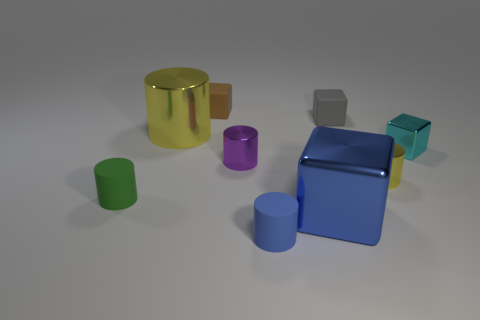There is a tiny object that is the same color as the big cylinder; what is it made of?
Your response must be concise. Metal. How many matte things are either tiny yellow things or blue blocks?
Make the answer very short. 0. How big is the brown rubber cube?
Provide a short and direct response. Small. Is the size of the cyan thing the same as the blue metal thing?
Your answer should be compact. No. There is a cylinder behind the tiny purple thing; what material is it?
Your answer should be very brief. Metal. There is a purple thing that is the same shape as the big yellow metallic object; what material is it?
Offer a terse response. Metal. Are there any rubber cubes to the right of the shiny cylinder to the right of the gray thing?
Offer a very short reply. No. Does the tiny brown thing have the same shape as the blue metal thing?
Your response must be concise. Yes. There is a small purple thing that is the same material as the tiny cyan block; what shape is it?
Ensure brevity in your answer.  Cylinder. There is a cylinder that is in front of the small green rubber object; does it have the same size as the yellow object that is in front of the tiny cyan shiny block?
Keep it short and to the point. Yes. 